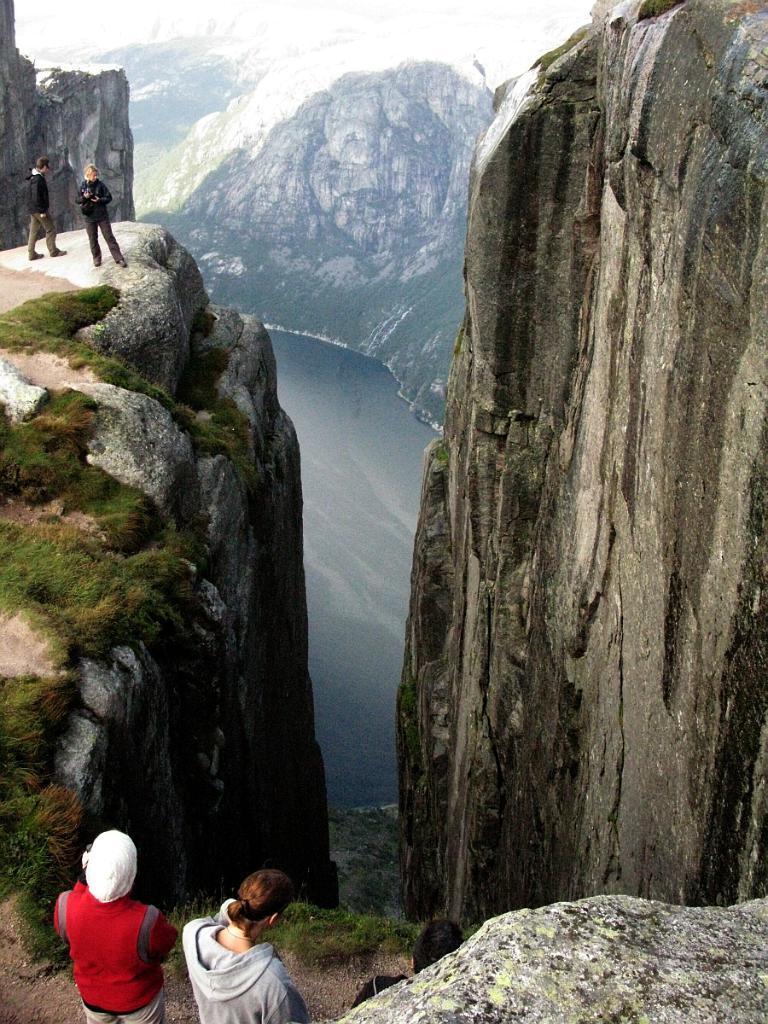In one or two sentences, can you explain what this image depicts? In this image there are a few people standing on the top edge of the rock, beside them there is water, in the background of the image there are mountains. 